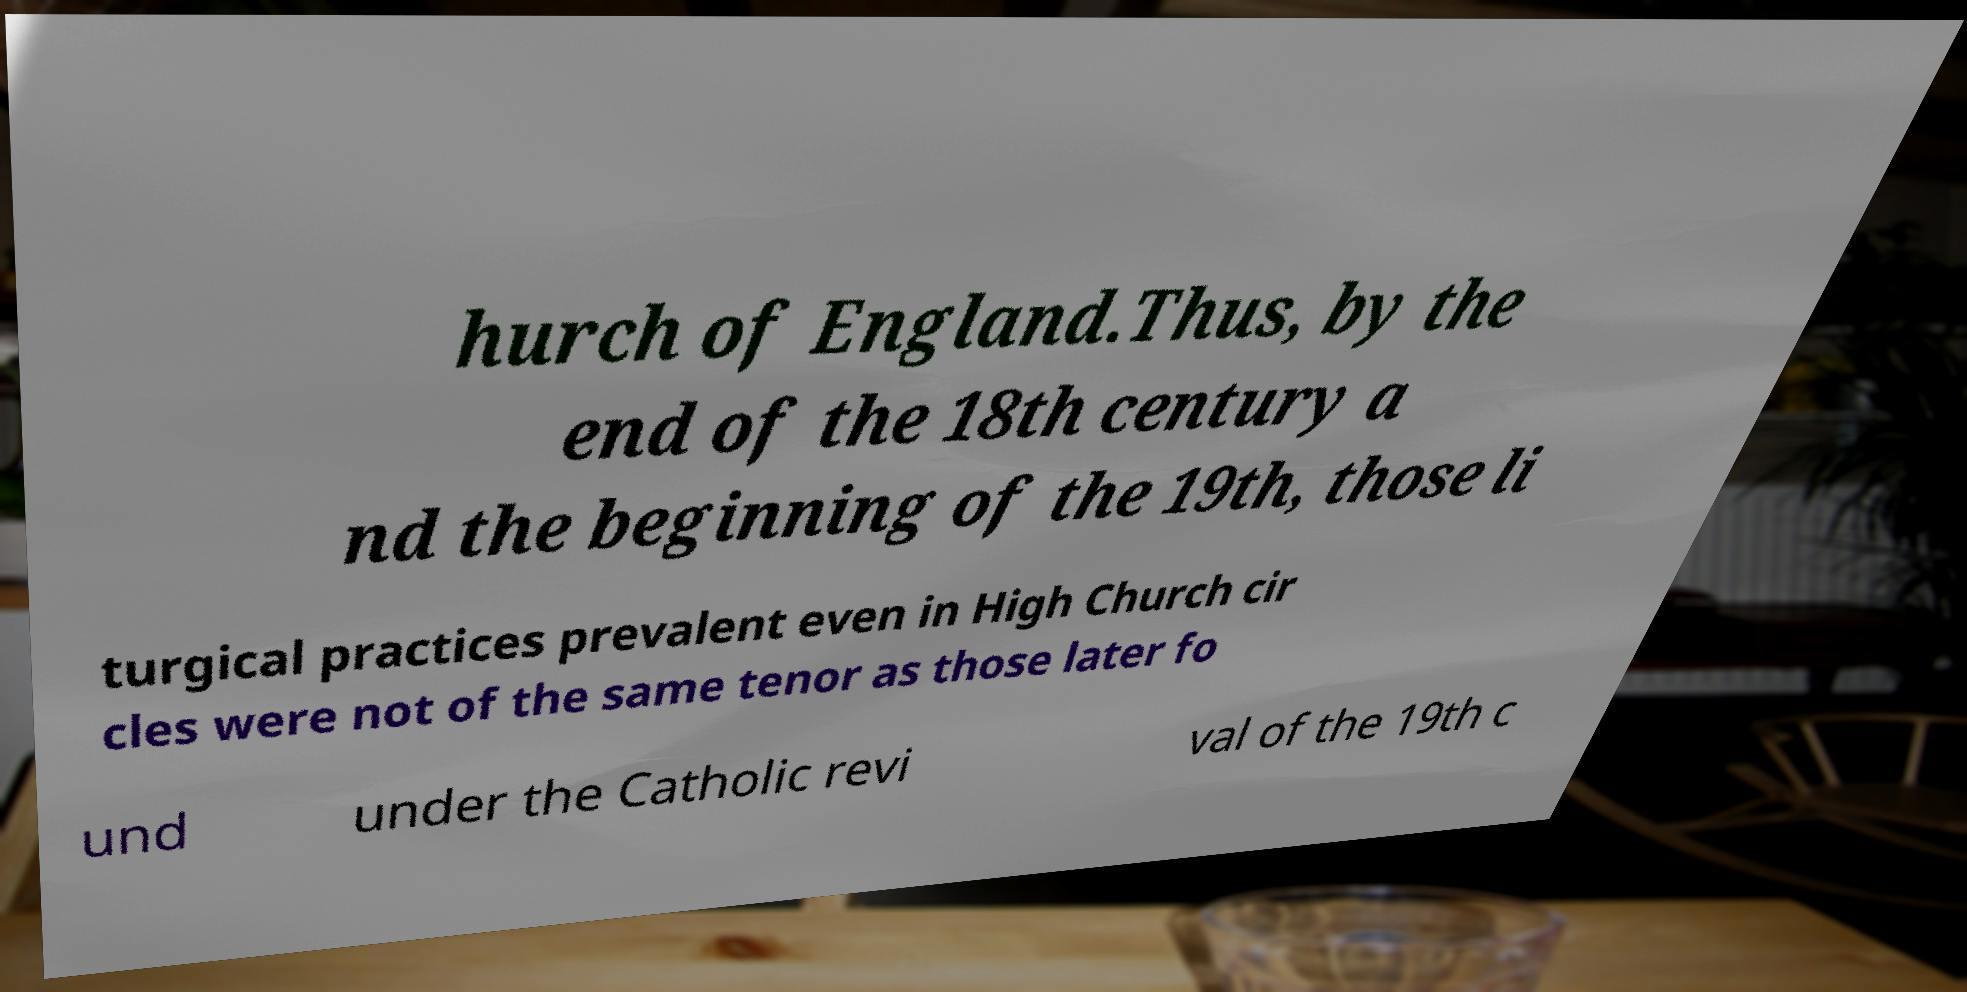Please read and relay the text visible in this image. What does it say? hurch of England.Thus, by the end of the 18th century a nd the beginning of the 19th, those li turgical practices prevalent even in High Church cir cles were not of the same tenor as those later fo und under the Catholic revi val of the 19th c 